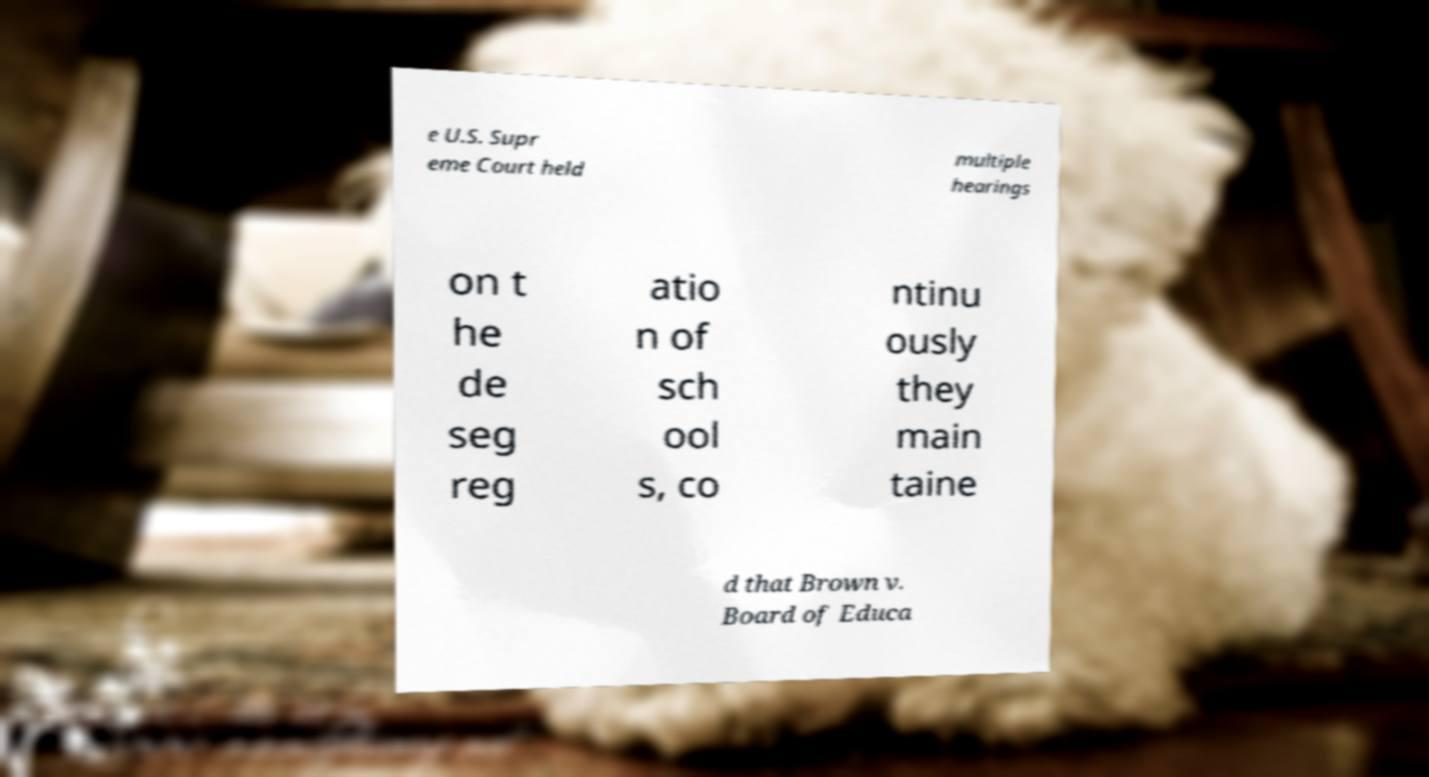Can you read and provide the text displayed in the image?This photo seems to have some interesting text. Can you extract and type it out for me? e U.S. Supr eme Court held multiple hearings on t he de seg reg atio n of sch ool s, co ntinu ously they main taine d that Brown v. Board of Educa 